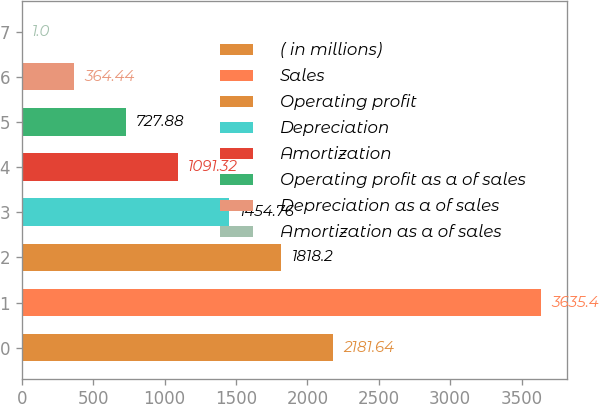Convert chart. <chart><loc_0><loc_0><loc_500><loc_500><bar_chart><fcel>( in millions)<fcel>Sales<fcel>Operating profit<fcel>Depreciation<fcel>Amortization<fcel>Operating profit as a of sales<fcel>Depreciation as a of sales<fcel>Amortization as a of sales<nl><fcel>2181.64<fcel>3635.4<fcel>1818.2<fcel>1454.76<fcel>1091.32<fcel>727.88<fcel>364.44<fcel>1<nl></chart> 